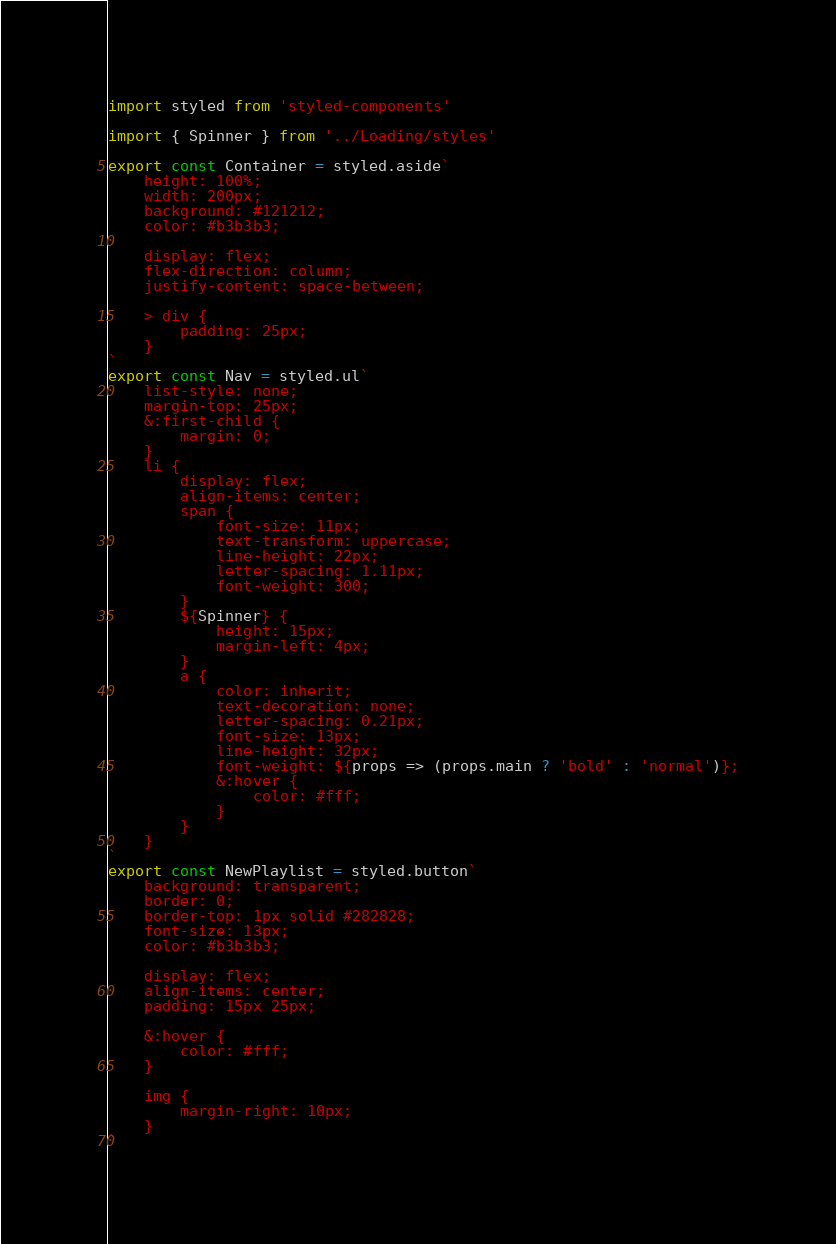<code> <loc_0><loc_0><loc_500><loc_500><_JavaScript_>import styled from 'styled-components'

import { Spinner } from '../Loading/styles'

export const Container = styled.aside`
    height: 100%;
    width: 200px;
    background: #121212;
    color: #b3b3b3;

    display: flex;
    flex-direction: column;
    justify-content: space-between;

    > div {
        padding: 25px;
    }
`
export const Nav = styled.ul`
    list-style: none;
    margin-top: 25px;
    &:first-child {
        margin: 0;
    }
    li {
        display: flex;
        align-items: center;
        span {
            font-size: 11px;
            text-transform: uppercase;
            line-height: 22px;
            letter-spacing: 1.11px;
            font-weight: 300;
        }
        ${Spinner} {
            height: 15px;
            margin-left: 4px;
        }
        a {
            color: inherit;
            text-decoration: none;
            letter-spacing: 0.21px;
            font-size: 13px;
            line-height: 32px;
            font-weight: ${props => (props.main ? 'bold' : 'normal')};
            &:hover {
                color: #fff;
            }
        }
    }
`
export const NewPlaylist = styled.button`
    background: transparent;
    border: 0;
    border-top: 1px solid #282828;
    font-size: 13px;
    color: #b3b3b3;

    display: flex;
    align-items: center;
    padding: 15px 25px;

    &:hover {
        color: #fff;
    }

    img {
        margin-right: 10px;
    }
`
</code> 